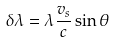<formula> <loc_0><loc_0><loc_500><loc_500>\delta \lambda = \lambda \frac { v _ { s } } { c } \sin \theta</formula> 